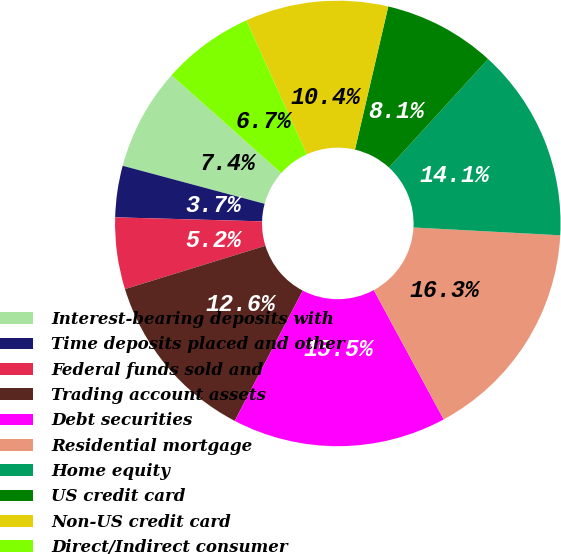Convert chart. <chart><loc_0><loc_0><loc_500><loc_500><pie_chart><fcel>Interest-bearing deposits with<fcel>Time deposits placed and other<fcel>Federal funds sold and<fcel>Trading account assets<fcel>Debt securities<fcel>Residential mortgage<fcel>Home equity<fcel>US credit card<fcel>Non-US credit card<fcel>Direct/Indirect consumer<nl><fcel>7.42%<fcel>3.73%<fcel>5.2%<fcel>12.58%<fcel>15.54%<fcel>16.27%<fcel>14.06%<fcel>8.15%<fcel>10.37%<fcel>6.68%<nl></chart> 